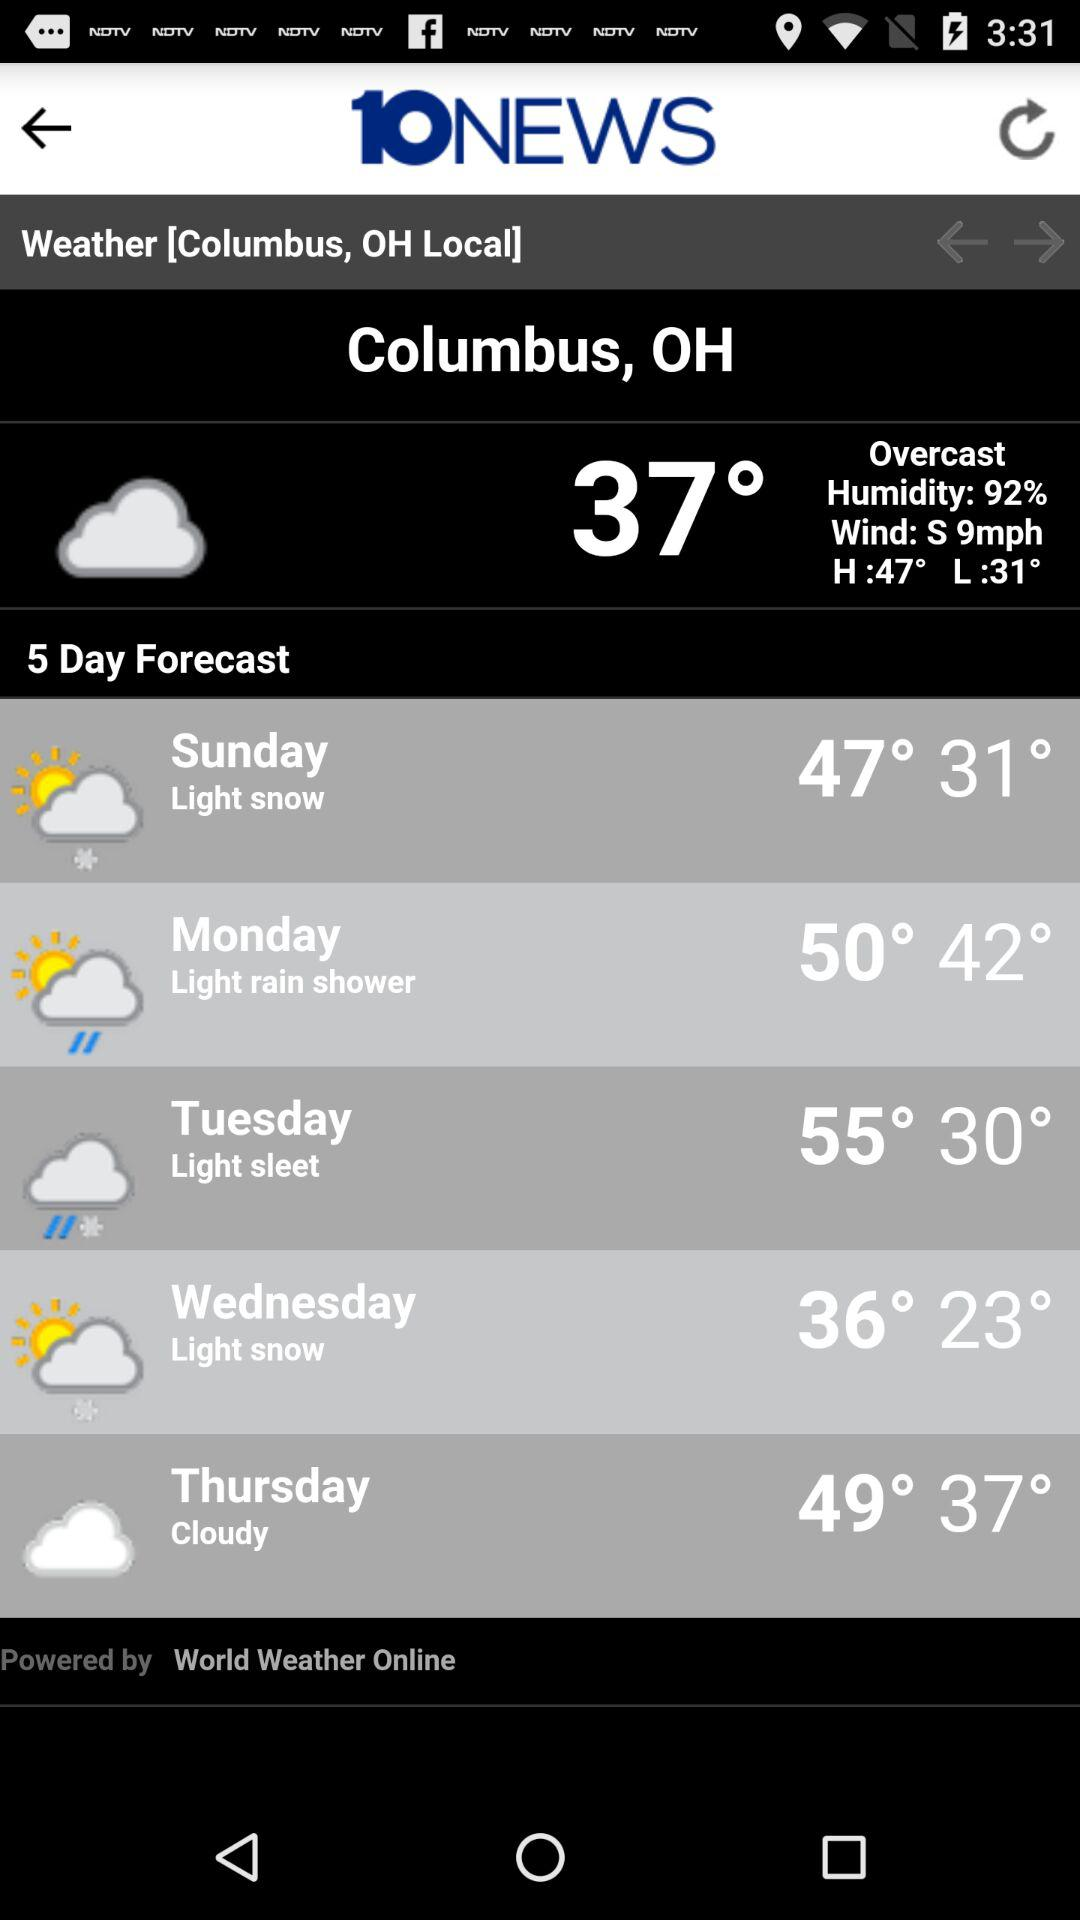For how many days is a weather forecast given? A weather forecast is given for 5 days. 